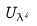<formula> <loc_0><loc_0><loc_500><loc_500>U _ { \lambda ^ { 4 } }</formula> 